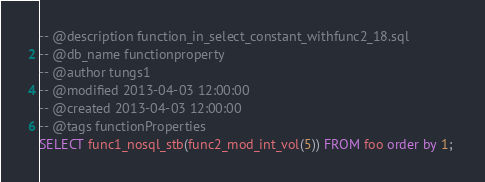Convert code to text. <code><loc_0><loc_0><loc_500><loc_500><_SQL_>-- @description function_in_select_constant_withfunc2_18.sql
-- @db_name functionproperty
-- @author tungs1
-- @modified 2013-04-03 12:00:00
-- @created 2013-04-03 12:00:00
-- @tags functionProperties 
SELECT func1_nosql_stb(func2_mod_int_vol(5)) FROM foo order by 1; 
</code> 